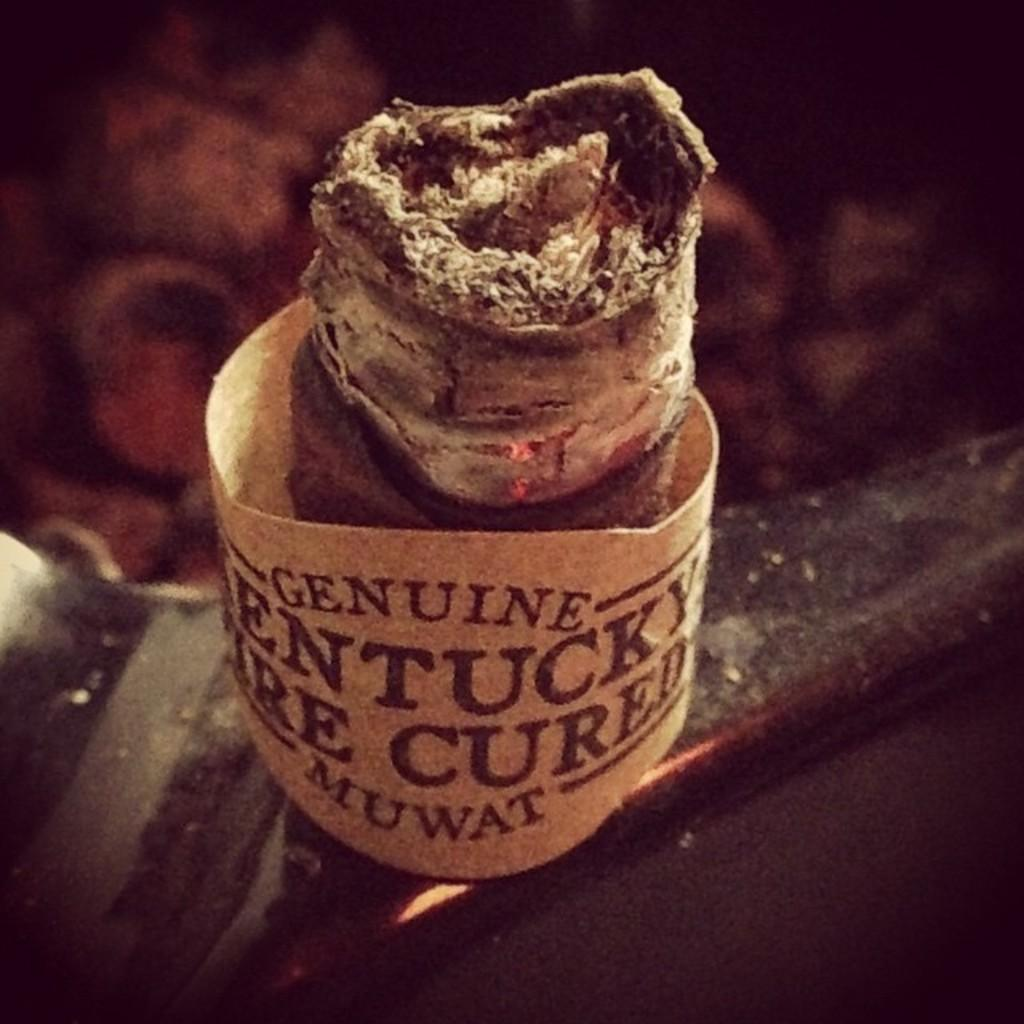What type of food can be seen in the image? The food in the image has a brown color. Can you describe the background of the image? The background of the image is blurred. Is there a girl writing a note expressing her hate for the food in the image? There is no girl or note present in the image, and the food is not being evaluated negatively. 